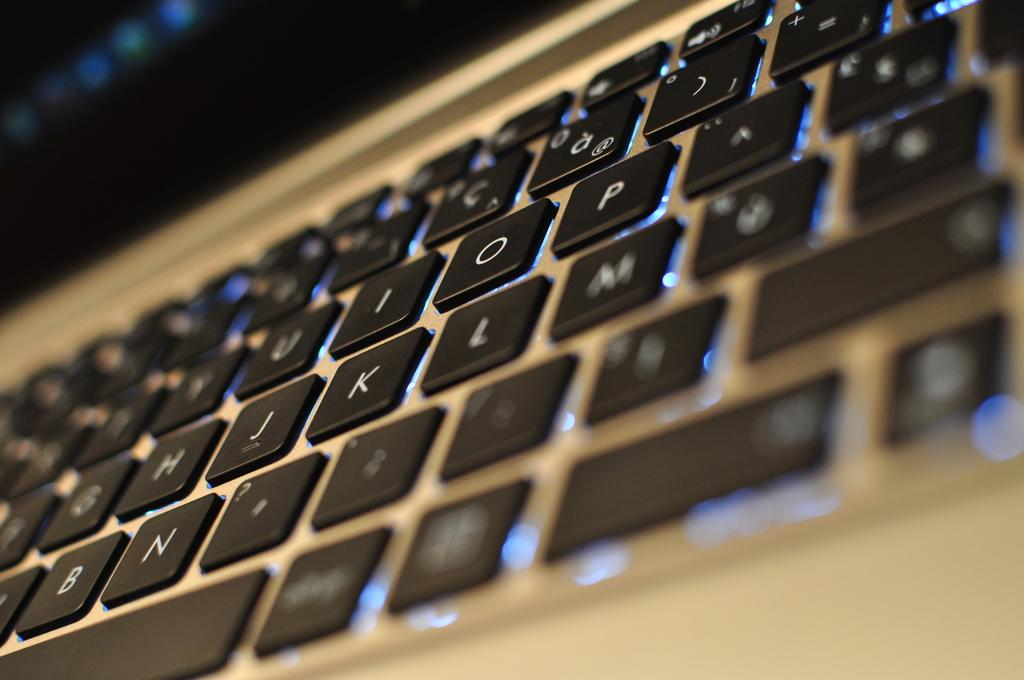<image>
Relay a brief, clear account of the picture shown. a macbook backlit keybaord with the numbers 'j,k and l' in the middle 